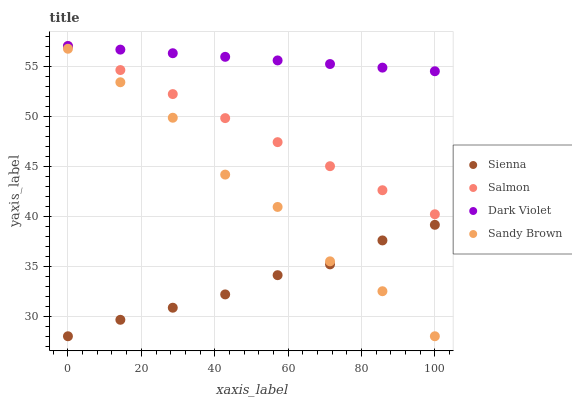Does Sienna have the minimum area under the curve?
Answer yes or no. Yes. Does Dark Violet have the maximum area under the curve?
Answer yes or no. Yes. Does Sandy Brown have the minimum area under the curve?
Answer yes or no. No. Does Sandy Brown have the maximum area under the curve?
Answer yes or no. No. Is Dark Violet the smoothest?
Answer yes or no. Yes. Is Sandy Brown the roughest?
Answer yes or no. Yes. Is Salmon the smoothest?
Answer yes or no. No. Is Salmon the roughest?
Answer yes or no. No. Does Sienna have the lowest value?
Answer yes or no. Yes. Does Salmon have the lowest value?
Answer yes or no. No. Does Dark Violet have the highest value?
Answer yes or no. Yes. Does Sandy Brown have the highest value?
Answer yes or no. No. Is Sienna less than Dark Violet?
Answer yes or no. Yes. Is Salmon greater than Sienna?
Answer yes or no. Yes. Does Dark Violet intersect Salmon?
Answer yes or no. Yes. Is Dark Violet less than Salmon?
Answer yes or no. No. Is Dark Violet greater than Salmon?
Answer yes or no. No. Does Sienna intersect Dark Violet?
Answer yes or no. No. 